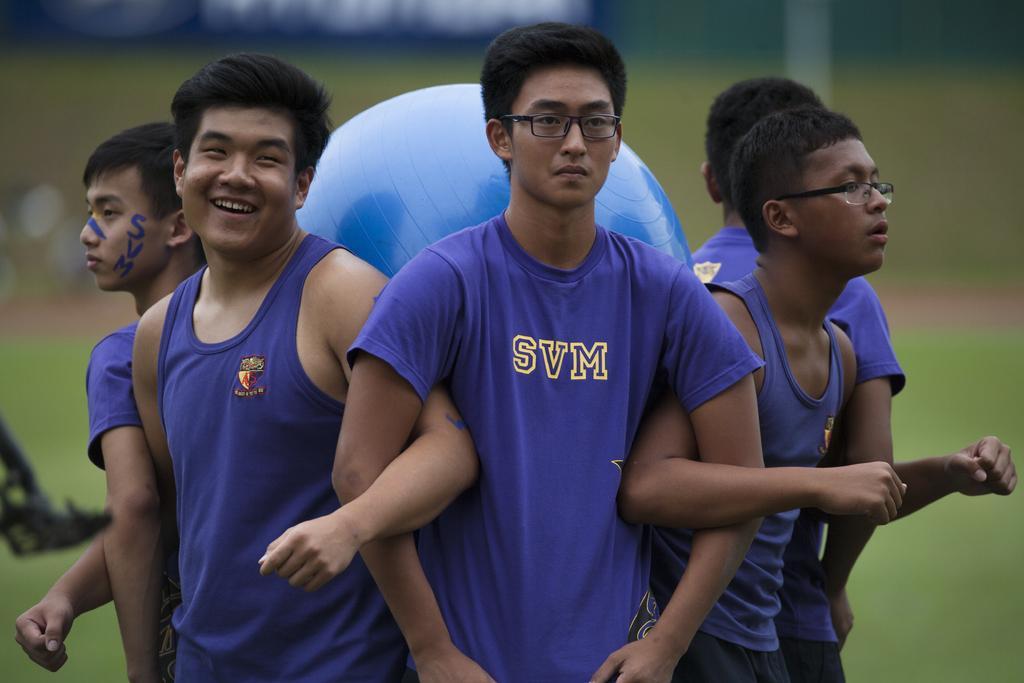Describe this image in one or two sentences. In this picture we can see a group of people and an exercise ball. Behind the people there is the blurred background. 